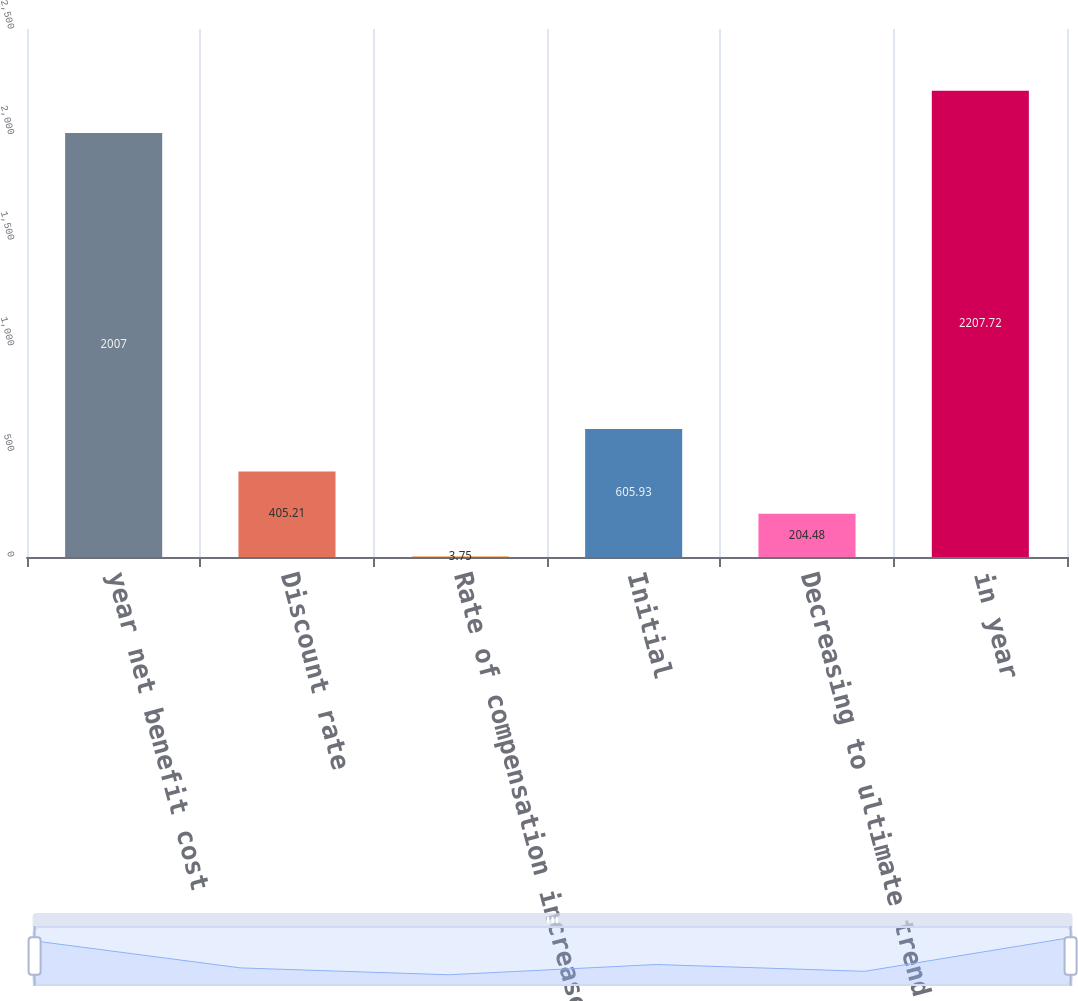Convert chart to OTSL. <chart><loc_0><loc_0><loc_500><loc_500><bar_chart><fcel>year net benefit cost<fcel>Discount rate<fcel>Rate of compensation increase<fcel>Initial<fcel>Decreasing to ultimate trend<fcel>in year<nl><fcel>2007<fcel>405.21<fcel>3.75<fcel>605.93<fcel>204.48<fcel>2207.72<nl></chart> 